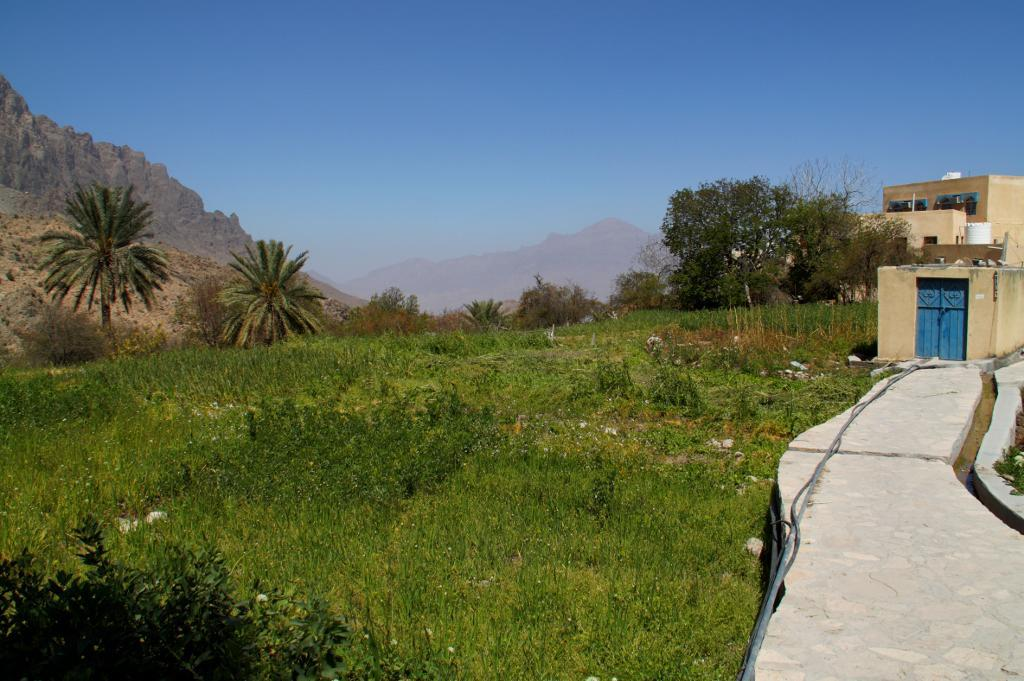What type of vegetation can be seen in the image? There are trees and plants in the image. What type of ground surface is present in the image? There are stones and grass in the image. What type of structures are visible in the image? There are buildings in the image, which have windows and doors. What natural feature can be seen in the background of the image? There are mountains in the image. What part of the natural environment is visible in the image? The sky is visible in the background of the image. What type of crack can be seen in the image? There is no crack present in the image. What route is visible in the image? There is no route visible in the image. 